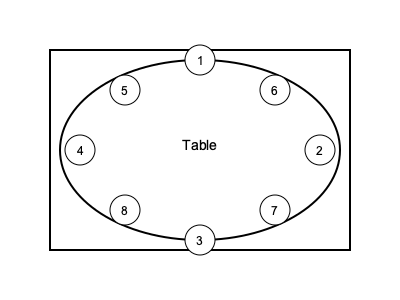As the host of a formal dinner party, you are arranging seating for eight guests. Given that the most honored guest should be seated to your right, and their spouse to your left, which seat numbers should be assigned to the guest of honor and their spouse, respectively? 1. In formal dining etiquette, the host typically sits at the head of the table, which is position 1 in this diagram.

2. The most honored guest should be seated to the host's right. This corresponds to position 2 in the diagram.

3. The spouse of the most honored guest should be seated to the host's left. This corresponds to position 4 in the diagram.

4. The remaining guests would be seated according to their rank or importance, alternating between right and left sides of the table, moving away from the host.

5. This arrangement allows for balanced conversation and maintains the proper hierarchy of guests according to traditional English nobility customs.
Answer: 2 and 4 